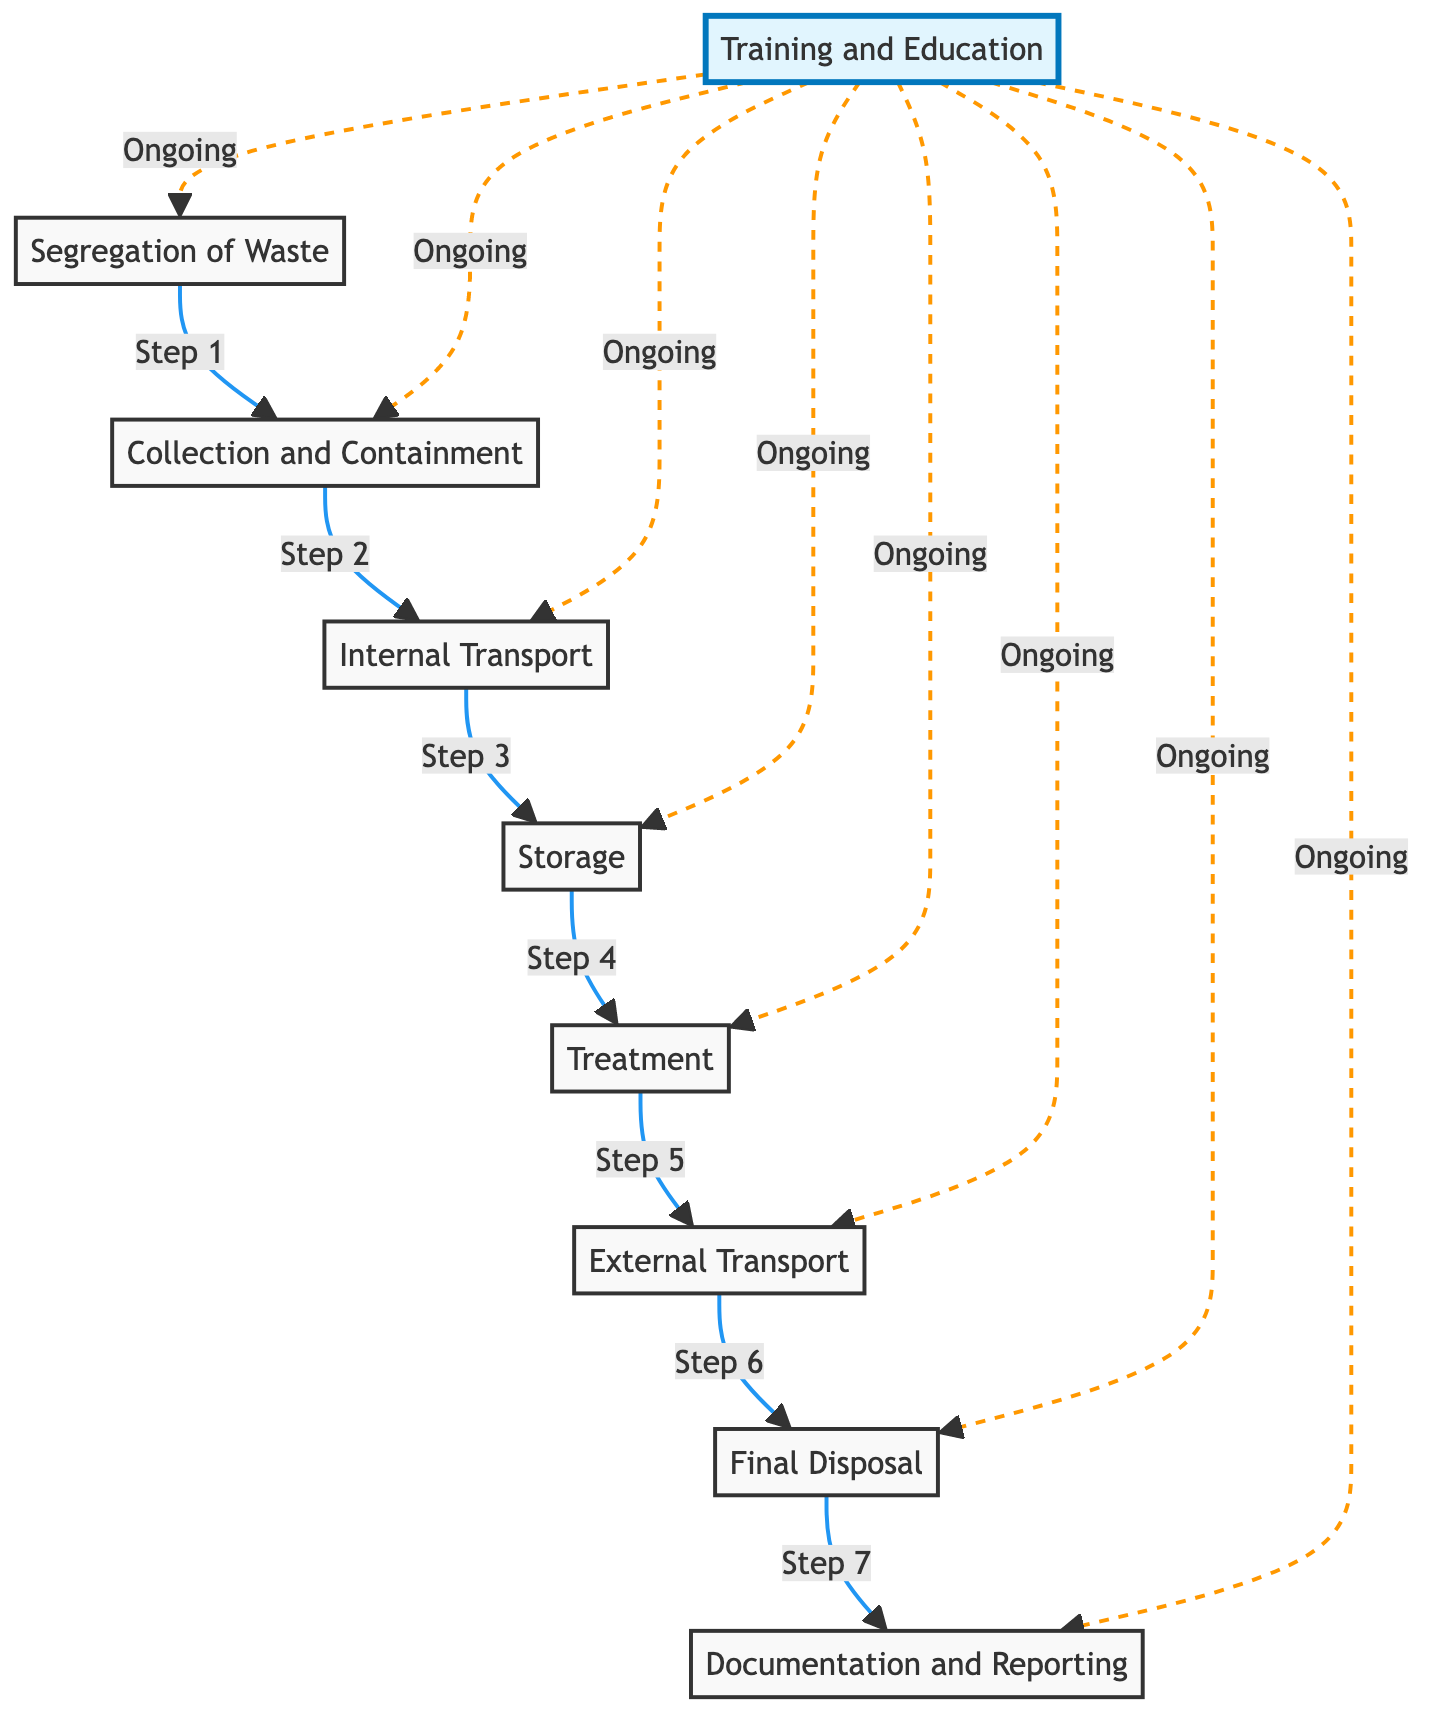What is the first step in the protocol? The first step in the protocol is "Segregation of Waste," as depicted in the flowchart. This identifies the initial action taken in the process of handling and disposing of medical waste.
Answer: Segregation of Waste How many main steps are in the protocol? The flowchart outlines a total of 8 main steps, which include segregation, collection, transport, storage, treatment, external transport, final disposal, and documentation.
Answer: 8 What color container is used for sharps waste? The flowchart specifies that a yellow container is used for sharps waste, indicating the correct classification for its collection and containment.
Answer: Yellow Which step comes after internal transport? Following the internal transport of waste, the next step in the protocol is "Storage," where the waste is kept securely within the healthcare facility.
Answer: Storage What is required for external transport of medical waste? It is necessary to use licensed and trained waste disposal contractors for the external transport of medical waste to ensure proper handling and compliance with regulations.
Answer: Licensed contractors What should be done with treated waste? Treated waste should be disposed of in sanitary landfills or other approved facilities, ensuring that it is handled safely after treatment.
Answer: Dispose in sanitary landfills How does training relate to the entire protocol? Training is an ongoing requirement that supports all steps in the protocol, ensuring that healthcare staff are knowledgeable and compliant with waste management practices across the entire process.
Answer: Ongoing training What is the last step in the disposal process? The last step in the disposal process is "Documentation and Reporting," which ensures that all activities related to waste management are recorded and reported to regulatory bodies as necessary.
Answer: Documentation and Reporting What is the purpose of color-coded containers? The purpose of color-coded containers is to categorize medical waste correctly, assisting in the proper collection and containment of different types of waste for safety and compliance.
Answer: Categorization of waste 